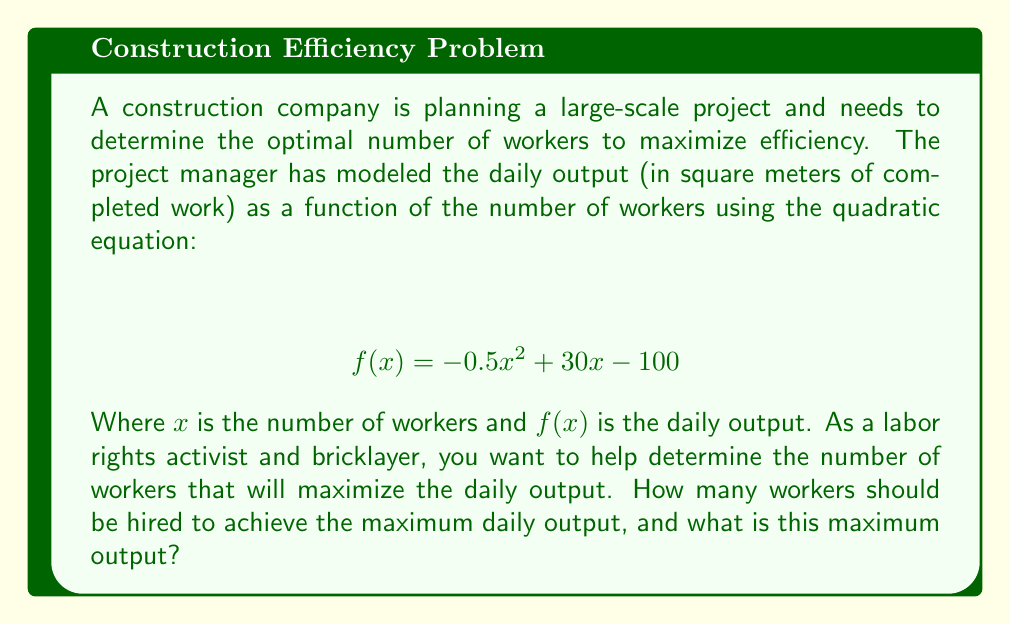Teach me how to tackle this problem. To solve this problem, we need to find the vertex of the parabola represented by the given quadratic function. The vertex will give us the maximum point of the function, which corresponds to the optimal number of workers and the maximum daily output.

For a quadratic function in the form $f(x) = ax^2 + bx + c$, the x-coordinate of the vertex is given by $x = -\frac{b}{2a}$.

In our case:
$a = -0.5$
$b = 30$
$c = -100$

1. Calculate the x-coordinate of the vertex:
   $$ x = -\frac{b}{2a} = -\frac{30}{2(-0.5)} = -\frac{30}{-1} = 30 $$

2. To find the maximum output, we substitute x = 30 into the original function:
   $$ f(30) = -0.5(30)^2 + 30(30) - 100 $$
   $$ = -0.5(900) + 900 - 100 $$
   $$ = -450 + 900 - 100 $$
   $$ = 350 $$

Therefore, the optimal number of workers is 30, and the maximum daily output is 350 square meters.
Answer: The optimal number of workers is 30, and the maximum daily output is 350 square meters. 